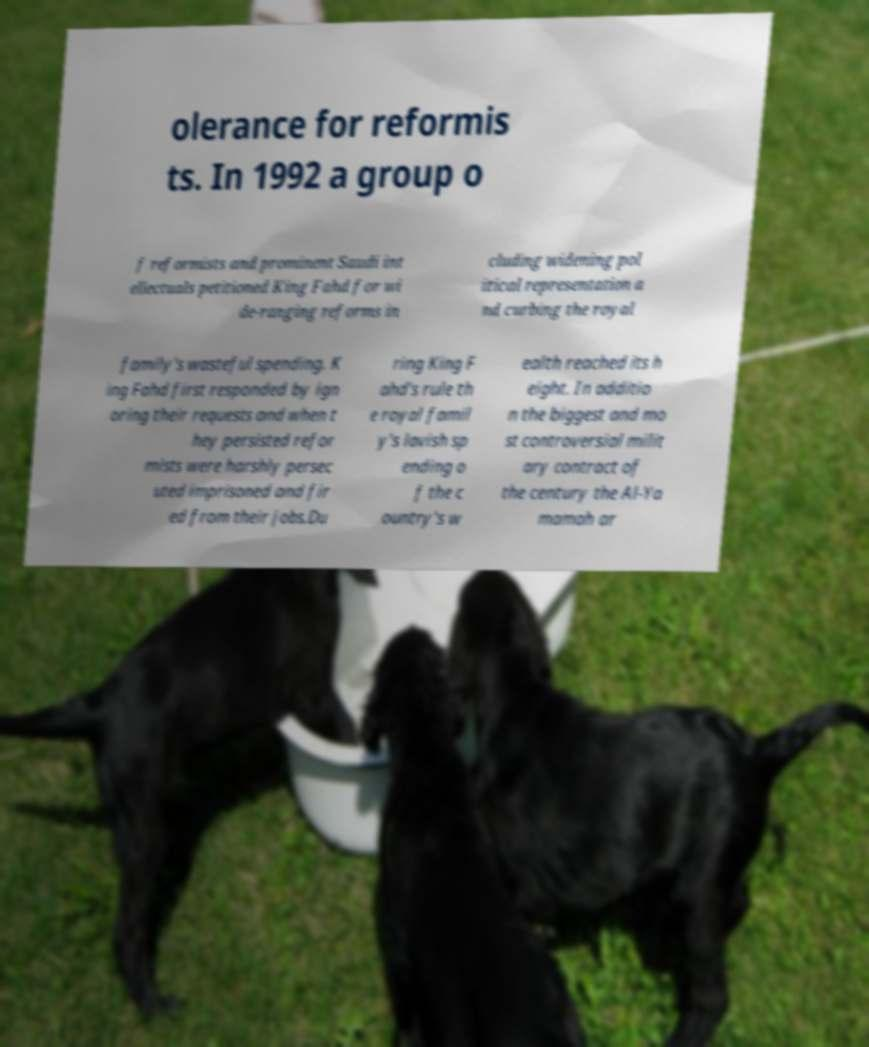Could you extract and type out the text from this image? olerance for reformis ts. In 1992 a group o f reformists and prominent Saudi int ellectuals petitioned King Fahd for wi de-ranging reforms in cluding widening pol itical representation a nd curbing the royal family's wasteful spending. K ing Fahd first responded by ign oring their requests and when t hey persisted refor mists were harshly persec uted imprisoned and fir ed from their jobs.Du ring King F ahd's rule th e royal famil y's lavish sp ending o f the c ountry's w ealth reached its h eight. In additio n the biggest and mo st controversial milit ary contract of the century the Al-Ya mamah ar 